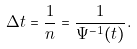Convert formula to latex. <formula><loc_0><loc_0><loc_500><loc_500>\Delta t = \frac { 1 } { n } = \frac { 1 } { \Psi ^ { - 1 } ( t ) } .</formula> 